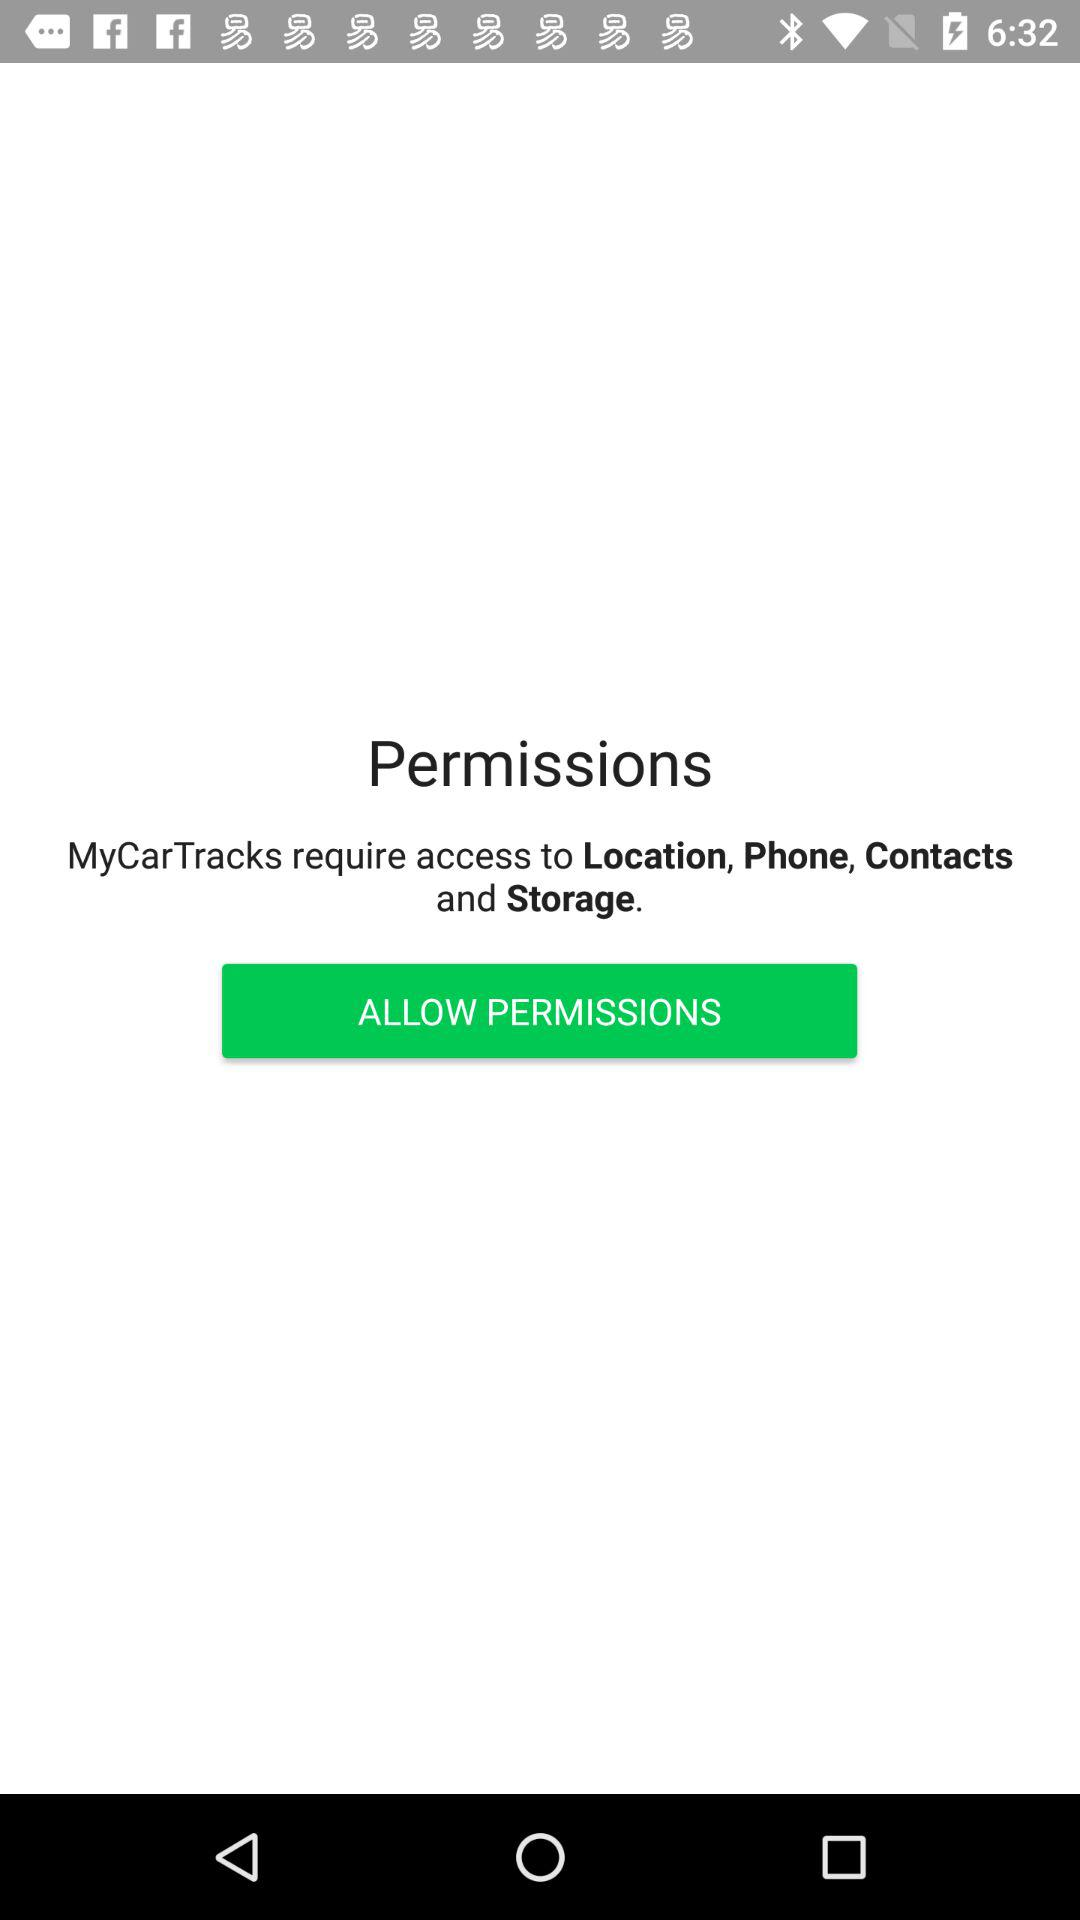What permissions are required for MyCarTracks? The permissions that are required for MyCarTracks are location, phone, contacts and storage. 